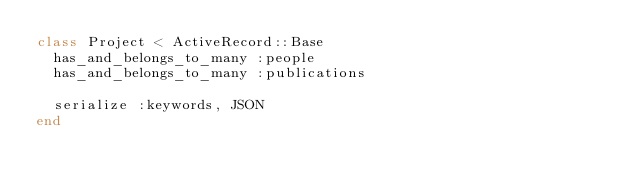Convert code to text. <code><loc_0><loc_0><loc_500><loc_500><_Ruby_>class Project < ActiveRecord::Base
  has_and_belongs_to_many :people
  has_and_belongs_to_many :publications

  serialize :keywords, JSON
end
</code> 